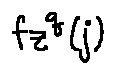Convert formula to latex. <formula><loc_0><loc_0><loc_500><loc_500>f _ { z } ^ { q } ( j )</formula> 